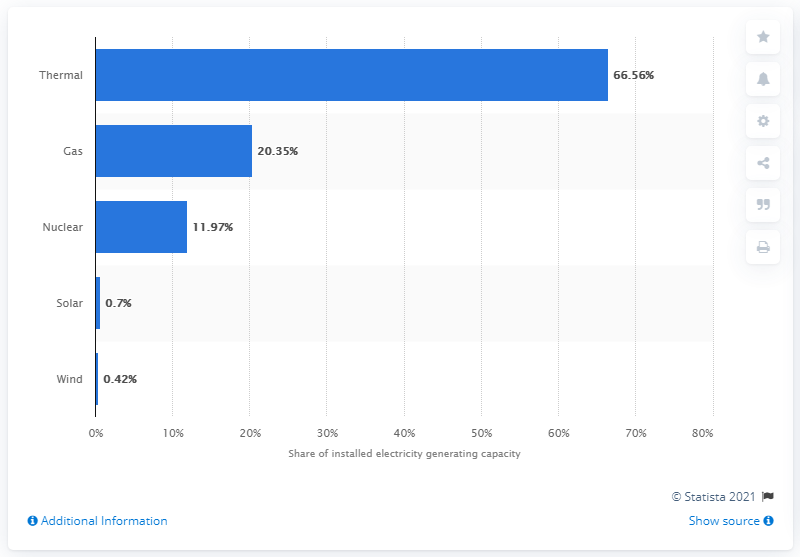Indicate a few pertinent items in this graphic. As of January 1, 2021, the installed capacity of thermal power plants in Russia was 66.56%. In 2020, the share of solar and wind energy plants in Russia's total installed capacity was 66.56%. 